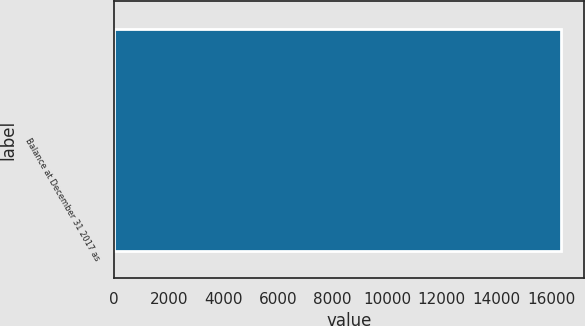Convert chart. <chart><loc_0><loc_0><loc_500><loc_500><bar_chart><fcel>Balance at December 31 2017 as<nl><fcel>16373<nl></chart> 